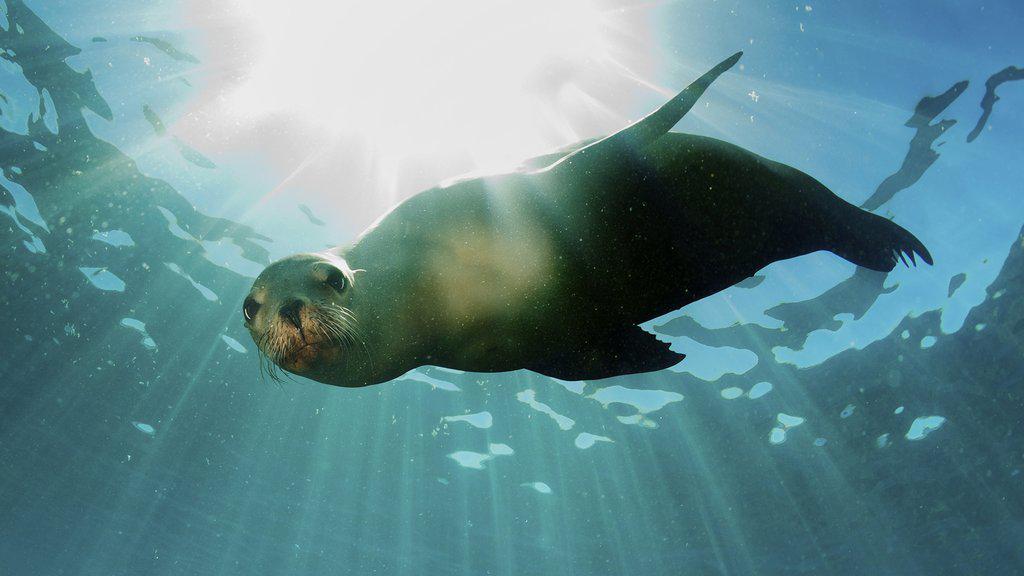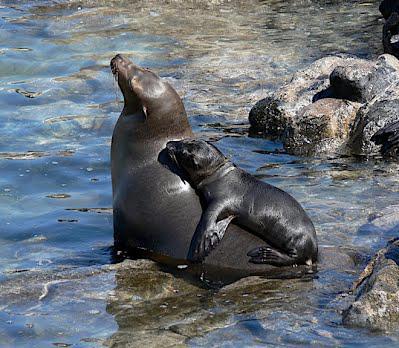The first image is the image on the left, the second image is the image on the right. For the images shown, is this caption "The right image contains two seals." true? Answer yes or no. Yes. The first image is the image on the left, the second image is the image on the right. Analyze the images presented: Is the assertion "The right image includes a sleek gray seal with raised right-turned head and body turned to the camera, perched on a large rock in front of blue-green water." valid? Answer yes or no. No. 